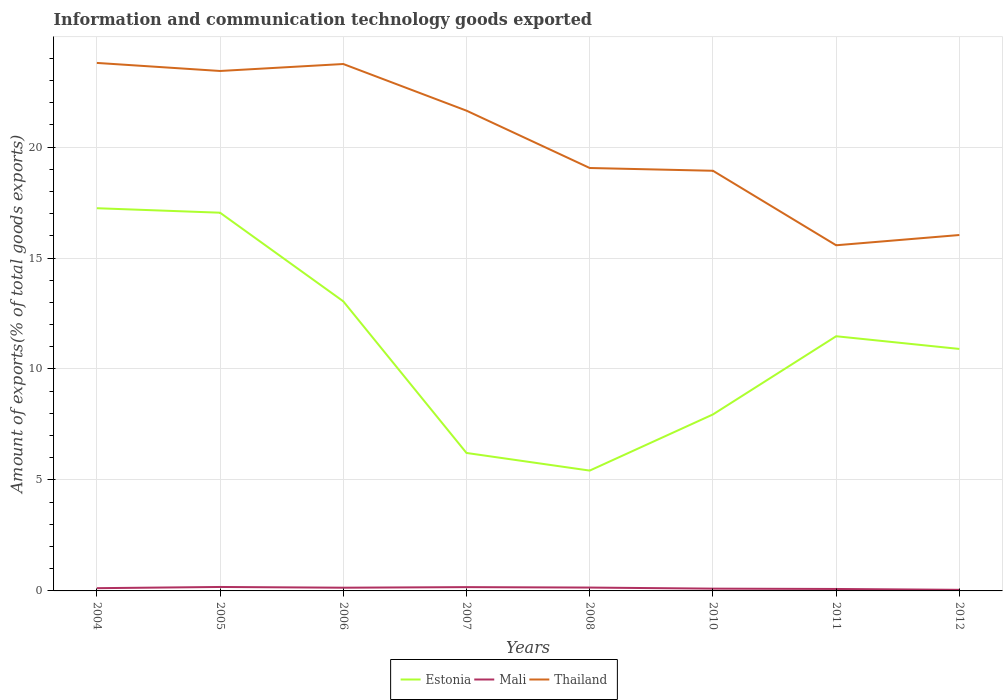Does the line corresponding to Mali intersect with the line corresponding to Thailand?
Offer a terse response. No. Across all years, what is the maximum amount of goods exported in Estonia?
Keep it short and to the point. 5.42. In which year was the amount of goods exported in Thailand maximum?
Offer a very short reply. 2011. What is the total amount of goods exported in Thailand in the graph?
Provide a succinct answer. 0.05. What is the difference between the highest and the second highest amount of goods exported in Thailand?
Provide a short and direct response. 8.22. What is the difference between the highest and the lowest amount of goods exported in Mali?
Your answer should be very brief. 4. How many lines are there?
Give a very brief answer. 3. Are the values on the major ticks of Y-axis written in scientific E-notation?
Your response must be concise. No. Does the graph contain any zero values?
Give a very brief answer. No. How many legend labels are there?
Your answer should be compact. 3. How are the legend labels stacked?
Ensure brevity in your answer.  Horizontal. What is the title of the graph?
Your answer should be compact. Information and communication technology goods exported. What is the label or title of the X-axis?
Ensure brevity in your answer.  Years. What is the label or title of the Y-axis?
Your answer should be compact. Amount of exports(% of total goods exports). What is the Amount of exports(% of total goods exports) of Estonia in 2004?
Your answer should be compact. 17.24. What is the Amount of exports(% of total goods exports) in Mali in 2004?
Provide a succinct answer. 0.12. What is the Amount of exports(% of total goods exports) in Thailand in 2004?
Your answer should be very brief. 23.79. What is the Amount of exports(% of total goods exports) of Estonia in 2005?
Your answer should be very brief. 17.04. What is the Amount of exports(% of total goods exports) of Mali in 2005?
Your response must be concise. 0.18. What is the Amount of exports(% of total goods exports) of Thailand in 2005?
Provide a succinct answer. 23.43. What is the Amount of exports(% of total goods exports) of Estonia in 2006?
Offer a very short reply. 13.05. What is the Amount of exports(% of total goods exports) in Mali in 2006?
Your response must be concise. 0.15. What is the Amount of exports(% of total goods exports) in Thailand in 2006?
Make the answer very short. 23.74. What is the Amount of exports(% of total goods exports) in Estonia in 2007?
Ensure brevity in your answer.  6.22. What is the Amount of exports(% of total goods exports) in Mali in 2007?
Make the answer very short. 0.17. What is the Amount of exports(% of total goods exports) in Thailand in 2007?
Provide a short and direct response. 21.64. What is the Amount of exports(% of total goods exports) of Estonia in 2008?
Keep it short and to the point. 5.42. What is the Amount of exports(% of total goods exports) in Mali in 2008?
Provide a succinct answer. 0.15. What is the Amount of exports(% of total goods exports) in Thailand in 2008?
Provide a short and direct response. 19.06. What is the Amount of exports(% of total goods exports) in Estonia in 2010?
Make the answer very short. 7.95. What is the Amount of exports(% of total goods exports) in Mali in 2010?
Provide a short and direct response. 0.1. What is the Amount of exports(% of total goods exports) in Thailand in 2010?
Provide a succinct answer. 18.93. What is the Amount of exports(% of total goods exports) in Estonia in 2011?
Give a very brief answer. 11.47. What is the Amount of exports(% of total goods exports) of Mali in 2011?
Your answer should be very brief. 0.09. What is the Amount of exports(% of total goods exports) of Thailand in 2011?
Your answer should be very brief. 15.57. What is the Amount of exports(% of total goods exports) in Estonia in 2012?
Ensure brevity in your answer.  10.9. What is the Amount of exports(% of total goods exports) of Mali in 2012?
Your answer should be very brief. 0.05. What is the Amount of exports(% of total goods exports) in Thailand in 2012?
Your response must be concise. 16.04. Across all years, what is the maximum Amount of exports(% of total goods exports) of Estonia?
Your answer should be compact. 17.24. Across all years, what is the maximum Amount of exports(% of total goods exports) in Mali?
Your answer should be very brief. 0.18. Across all years, what is the maximum Amount of exports(% of total goods exports) of Thailand?
Your answer should be very brief. 23.79. Across all years, what is the minimum Amount of exports(% of total goods exports) in Estonia?
Ensure brevity in your answer.  5.42. Across all years, what is the minimum Amount of exports(% of total goods exports) in Mali?
Make the answer very short. 0.05. Across all years, what is the minimum Amount of exports(% of total goods exports) of Thailand?
Provide a short and direct response. 15.57. What is the total Amount of exports(% of total goods exports) of Estonia in the graph?
Provide a succinct answer. 89.3. What is the total Amount of exports(% of total goods exports) of Mali in the graph?
Give a very brief answer. 1.01. What is the total Amount of exports(% of total goods exports) in Thailand in the graph?
Your answer should be compact. 162.19. What is the difference between the Amount of exports(% of total goods exports) in Estonia in 2004 and that in 2005?
Offer a terse response. 0.2. What is the difference between the Amount of exports(% of total goods exports) of Mali in 2004 and that in 2005?
Offer a terse response. -0.05. What is the difference between the Amount of exports(% of total goods exports) in Thailand in 2004 and that in 2005?
Make the answer very short. 0.36. What is the difference between the Amount of exports(% of total goods exports) of Estonia in 2004 and that in 2006?
Keep it short and to the point. 4.19. What is the difference between the Amount of exports(% of total goods exports) in Mali in 2004 and that in 2006?
Ensure brevity in your answer.  -0.02. What is the difference between the Amount of exports(% of total goods exports) of Thailand in 2004 and that in 2006?
Give a very brief answer. 0.05. What is the difference between the Amount of exports(% of total goods exports) in Estonia in 2004 and that in 2007?
Your response must be concise. 11.03. What is the difference between the Amount of exports(% of total goods exports) in Mali in 2004 and that in 2007?
Make the answer very short. -0.05. What is the difference between the Amount of exports(% of total goods exports) in Thailand in 2004 and that in 2007?
Provide a succinct answer. 2.15. What is the difference between the Amount of exports(% of total goods exports) of Estonia in 2004 and that in 2008?
Provide a short and direct response. 11.82. What is the difference between the Amount of exports(% of total goods exports) in Mali in 2004 and that in 2008?
Your response must be concise. -0.03. What is the difference between the Amount of exports(% of total goods exports) of Thailand in 2004 and that in 2008?
Your answer should be very brief. 4.73. What is the difference between the Amount of exports(% of total goods exports) in Estonia in 2004 and that in 2010?
Give a very brief answer. 9.29. What is the difference between the Amount of exports(% of total goods exports) of Mali in 2004 and that in 2010?
Ensure brevity in your answer.  0.02. What is the difference between the Amount of exports(% of total goods exports) of Thailand in 2004 and that in 2010?
Your answer should be very brief. 4.86. What is the difference between the Amount of exports(% of total goods exports) of Estonia in 2004 and that in 2011?
Your answer should be compact. 5.77. What is the difference between the Amount of exports(% of total goods exports) in Mali in 2004 and that in 2011?
Offer a terse response. 0.04. What is the difference between the Amount of exports(% of total goods exports) of Thailand in 2004 and that in 2011?
Keep it short and to the point. 8.22. What is the difference between the Amount of exports(% of total goods exports) in Estonia in 2004 and that in 2012?
Make the answer very short. 6.34. What is the difference between the Amount of exports(% of total goods exports) in Mali in 2004 and that in 2012?
Keep it short and to the point. 0.07. What is the difference between the Amount of exports(% of total goods exports) in Thailand in 2004 and that in 2012?
Make the answer very short. 7.75. What is the difference between the Amount of exports(% of total goods exports) of Estonia in 2005 and that in 2006?
Keep it short and to the point. 3.99. What is the difference between the Amount of exports(% of total goods exports) in Mali in 2005 and that in 2006?
Ensure brevity in your answer.  0.03. What is the difference between the Amount of exports(% of total goods exports) in Thailand in 2005 and that in 2006?
Provide a short and direct response. -0.31. What is the difference between the Amount of exports(% of total goods exports) of Estonia in 2005 and that in 2007?
Make the answer very short. 10.82. What is the difference between the Amount of exports(% of total goods exports) of Mali in 2005 and that in 2007?
Provide a short and direct response. 0.01. What is the difference between the Amount of exports(% of total goods exports) in Thailand in 2005 and that in 2007?
Provide a succinct answer. 1.79. What is the difference between the Amount of exports(% of total goods exports) of Estonia in 2005 and that in 2008?
Ensure brevity in your answer.  11.62. What is the difference between the Amount of exports(% of total goods exports) in Mali in 2005 and that in 2008?
Make the answer very short. 0.03. What is the difference between the Amount of exports(% of total goods exports) in Thailand in 2005 and that in 2008?
Offer a very short reply. 4.37. What is the difference between the Amount of exports(% of total goods exports) of Estonia in 2005 and that in 2010?
Make the answer very short. 9.09. What is the difference between the Amount of exports(% of total goods exports) in Mali in 2005 and that in 2010?
Offer a terse response. 0.07. What is the difference between the Amount of exports(% of total goods exports) of Thailand in 2005 and that in 2010?
Offer a terse response. 4.5. What is the difference between the Amount of exports(% of total goods exports) of Estonia in 2005 and that in 2011?
Ensure brevity in your answer.  5.57. What is the difference between the Amount of exports(% of total goods exports) of Mali in 2005 and that in 2011?
Ensure brevity in your answer.  0.09. What is the difference between the Amount of exports(% of total goods exports) of Thailand in 2005 and that in 2011?
Make the answer very short. 7.85. What is the difference between the Amount of exports(% of total goods exports) of Estonia in 2005 and that in 2012?
Ensure brevity in your answer.  6.14. What is the difference between the Amount of exports(% of total goods exports) in Mali in 2005 and that in 2012?
Offer a very short reply. 0.13. What is the difference between the Amount of exports(% of total goods exports) in Thailand in 2005 and that in 2012?
Your answer should be very brief. 7.39. What is the difference between the Amount of exports(% of total goods exports) in Estonia in 2006 and that in 2007?
Offer a terse response. 6.83. What is the difference between the Amount of exports(% of total goods exports) in Mali in 2006 and that in 2007?
Make the answer very short. -0.03. What is the difference between the Amount of exports(% of total goods exports) in Thailand in 2006 and that in 2007?
Offer a terse response. 2.1. What is the difference between the Amount of exports(% of total goods exports) of Estonia in 2006 and that in 2008?
Offer a very short reply. 7.63. What is the difference between the Amount of exports(% of total goods exports) in Mali in 2006 and that in 2008?
Your response must be concise. -0.01. What is the difference between the Amount of exports(% of total goods exports) in Thailand in 2006 and that in 2008?
Offer a terse response. 4.69. What is the difference between the Amount of exports(% of total goods exports) in Estonia in 2006 and that in 2010?
Give a very brief answer. 5.1. What is the difference between the Amount of exports(% of total goods exports) in Mali in 2006 and that in 2010?
Your answer should be very brief. 0.04. What is the difference between the Amount of exports(% of total goods exports) of Thailand in 2006 and that in 2010?
Your answer should be compact. 4.81. What is the difference between the Amount of exports(% of total goods exports) in Estonia in 2006 and that in 2011?
Provide a short and direct response. 1.57. What is the difference between the Amount of exports(% of total goods exports) of Mali in 2006 and that in 2011?
Ensure brevity in your answer.  0.06. What is the difference between the Amount of exports(% of total goods exports) in Thailand in 2006 and that in 2011?
Provide a succinct answer. 8.17. What is the difference between the Amount of exports(% of total goods exports) of Estonia in 2006 and that in 2012?
Ensure brevity in your answer.  2.15. What is the difference between the Amount of exports(% of total goods exports) in Mali in 2006 and that in 2012?
Give a very brief answer. 0.1. What is the difference between the Amount of exports(% of total goods exports) of Thailand in 2006 and that in 2012?
Make the answer very short. 7.7. What is the difference between the Amount of exports(% of total goods exports) in Estonia in 2007 and that in 2008?
Give a very brief answer. 0.79. What is the difference between the Amount of exports(% of total goods exports) in Mali in 2007 and that in 2008?
Your answer should be compact. 0.02. What is the difference between the Amount of exports(% of total goods exports) in Thailand in 2007 and that in 2008?
Keep it short and to the point. 2.58. What is the difference between the Amount of exports(% of total goods exports) in Estonia in 2007 and that in 2010?
Ensure brevity in your answer.  -1.74. What is the difference between the Amount of exports(% of total goods exports) in Mali in 2007 and that in 2010?
Your answer should be compact. 0.07. What is the difference between the Amount of exports(% of total goods exports) of Thailand in 2007 and that in 2010?
Your response must be concise. 2.71. What is the difference between the Amount of exports(% of total goods exports) of Estonia in 2007 and that in 2011?
Your answer should be very brief. -5.26. What is the difference between the Amount of exports(% of total goods exports) in Mali in 2007 and that in 2011?
Keep it short and to the point. 0.08. What is the difference between the Amount of exports(% of total goods exports) of Thailand in 2007 and that in 2011?
Make the answer very short. 6.06. What is the difference between the Amount of exports(% of total goods exports) in Estonia in 2007 and that in 2012?
Provide a short and direct response. -4.69. What is the difference between the Amount of exports(% of total goods exports) in Mali in 2007 and that in 2012?
Provide a succinct answer. 0.12. What is the difference between the Amount of exports(% of total goods exports) of Thailand in 2007 and that in 2012?
Provide a short and direct response. 5.6. What is the difference between the Amount of exports(% of total goods exports) in Estonia in 2008 and that in 2010?
Give a very brief answer. -2.53. What is the difference between the Amount of exports(% of total goods exports) of Mali in 2008 and that in 2010?
Provide a short and direct response. 0.05. What is the difference between the Amount of exports(% of total goods exports) in Thailand in 2008 and that in 2010?
Offer a very short reply. 0.12. What is the difference between the Amount of exports(% of total goods exports) of Estonia in 2008 and that in 2011?
Provide a succinct answer. -6.05. What is the difference between the Amount of exports(% of total goods exports) of Mali in 2008 and that in 2011?
Provide a short and direct response. 0.06. What is the difference between the Amount of exports(% of total goods exports) of Thailand in 2008 and that in 2011?
Give a very brief answer. 3.48. What is the difference between the Amount of exports(% of total goods exports) in Estonia in 2008 and that in 2012?
Offer a terse response. -5.48. What is the difference between the Amount of exports(% of total goods exports) of Mali in 2008 and that in 2012?
Offer a terse response. 0.1. What is the difference between the Amount of exports(% of total goods exports) of Thailand in 2008 and that in 2012?
Ensure brevity in your answer.  3.02. What is the difference between the Amount of exports(% of total goods exports) in Estonia in 2010 and that in 2011?
Your response must be concise. -3.52. What is the difference between the Amount of exports(% of total goods exports) of Mali in 2010 and that in 2011?
Ensure brevity in your answer.  0.02. What is the difference between the Amount of exports(% of total goods exports) in Thailand in 2010 and that in 2011?
Provide a succinct answer. 3.36. What is the difference between the Amount of exports(% of total goods exports) of Estonia in 2010 and that in 2012?
Provide a short and direct response. -2.95. What is the difference between the Amount of exports(% of total goods exports) in Mali in 2010 and that in 2012?
Ensure brevity in your answer.  0.05. What is the difference between the Amount of exports(% of total goods exports) of Thailand in 2010 and that in 2012?
Your response must be concise. 2.9. What is the difference between the Amount of exports(% of total goods exports) of Estonia in 2011 and that in 2012?
Make the answer very short. 0.57. What is the difference between the Amount of exports(% of total goods exports) in Mali in 2011 and that in 2012?
Offer a terse response. 0.04. What is the difference between the Amount of exports(% of total goods exports) in Thailand in 2011 and that in 2012?
Ensure brevity in your answer.  -0.46. What is the difference between the Amount of exports(% of total goods exports) of Estonia in 2004 and the Amount of exports(% of total goods exports) of Mali in 2005?
Offer a very short reply. 17.07. What is the difference between the Amount of exports(% of total goods exports) of Estonia in 2004 and the Amount of exports(% of total goods exports) of Thailand in 2005?
Your answer should be very brief. -6.18. What is the difference between the Amount of exports(% of total goods exports) of Mali in 2004 and the Amount of exports(% of total goods exports) of Thailand in 2005?
Provide a short and direct response. -23.3. What is the difference between the Amount of exports(% of total goods exports) in Estonia in 2004 and the Amount of exports(% of total goods exports) in Mali in 2006?
Your answer should be very brief. 17.1. What is the difference between the Amount of exports(% of total goods exports) of Estonia in 2004 and the Amount of exports(% of total goods exports) of Thailand in 2006?
Your answer should be compact. -6.5. What is the difference between the Amount of exports(% of total goods exports) in Mali in 2004 and the Amount of exports(% of total goods exports) in Thailand in 2006?
Give a very brief answer. -23.62. What is the difference between the Amount of exports(% of total goods exports) of Estonia in 2004 and the Amount of exports(% of total goods exports) of Mali in 2007?
Ensure brevity in your answer.  17.07. What is the difference between the Amount of exports(% of total goods exports) of Estonia in 2004 and the Amount of exports(% of total goods exports) of Thailand in 2007?
Provide a short and direct response. -4.4. What is the difference between the Amount of exports(% of total goods exports) of Mali in 2004 and the Amount of exports(% of total goods exports) of Thailand in 2007?
Keep it short and to the point. -21.51. What is the difference between the Amount of exports(% of total goods exports) in Estonia in 2004 and the Amount of exports(% of total goods exports) in Mali in 2008?
Keep it short and to the point. 17.09. What is the difference between the Amount of exports(% of total goods exports) of Estonia in 2004 and the Amount of exports(% of total goods exports) of Thailand in 2008?
Offer a terse response. -1.81. What is the difference between the Amount of exports(% of total goods exports) in Mali in 2004 and the Amount of exports(% of total goods exports) in Thailand in 2008?
Your response must be concise. -18.93. What is the difference between the Amount of exports(% of total goods exports) in Estonia in 2004 and the Amount of exports(% of total goods exports) in Mali in 2010?
Offer a terse response. 17.14. What is the difference between the Amount of exports(% of total goods exports) in Estonia in 2004 and the Amount of exports(% of total goods exports) in Thailand in 2010?
Keep it short and to the point. -1.69. What is the difference between the Amount of exports(% of total goods exports) of Mali in 2004 and the Amount of exports(% of total goods exports) of Thailand in 2010?
Your answer should be very brief. -18.81. What is the difference between the Amount of exports(% of total goods exports) in Estonia in 2004 and the Amount of exports(% of total goods exports) in Mali in 2011?
Provide a short and direct response. 17.16. What is the difference between the Amount of exports(% of total goods exports) in Estonia in 2004 and the Amount of exports(% of total goods exports) in Thailand in 2011?
Offer a terse response. 1.67. What is the difference between the Amount of exports(% of total goods exports) of Mali in 2004 and the Amount of exports(% of total goods exports) of Thailand in 2011?
Give a very brief answer. -15.45. What is the difference between the Amount of exports(% of total goods exports) of Estonia in 2004 and the Amount of exports(% of total goods exports) of Mali in 2012?
Provide a short and direct response. 17.19. What is the difference between the Amount of exports(% of total goods exports) in Estonia in 2004 and the Amount of exports(% of total goods exports) in Thailand in 2012?
Your answer should be compact. 1.21. What is the difference between the Amount of exports(% of total goods exports) in Mali in 2004 and the Amount of exports(% of total goods exports) in Thailand in 2012?
Your response must be concise. -15.91. What is the difference between the Amount of exports(% of total goods exports) of Estonia in 2005 and the Amount of exports(% of total goods exports) of Mali in 2006?
Your answer should be compact. 16.9. What is the difference between the Amount of exports(% of total goods exports) in Estonia in 2005 and the Amount of exports(% of total goods exports) in Thailand in 2006?
Your answer should be very brief. -6.7. What is the difference between the Amount of exports(% of total goods exports) of Mali in 2005 and the Amount of exports(% of total goods exports) of Thailand in 2006?
Your answer should be compact. -23.56. What is the difference between the Amount of exports(% of total goods exports) in Estonia in 2005 and the Amount of exports(% of total goods exports) in Mali in 2007?
Your answer should be compact. 16.87. What is the difference between the Amount of exports(% of total goods exports) of Estonia in 2005 and the Amount of exports(% of total goods exports) of Thailand in 2007?
Make the answer very short. -4.6. What is the difference between the Amount of exports(% of total goods exports) of Mali in 2005 and the Amount of exports(% of total goods exports) of Thailand in 2007?
Make the answer very short. -21.46. What is the difference between the Amount of exports(% of total goods exports) of Estonia in 2005 and the Amount of exports(% of total goods exports) of Mali in 2008?
Ensure brevity in your answer.  16.89. What is the difference between the Amount of exports(% of total goods exports) in Estonia in 2005 and the Amount of exports(% of total goods exports) in Thailand in 2008?
Keep it short and to the point. -2.01. What is the difference between the Amount of exports(% of total goods exports) in Mali in 2005 and the Amount of exports(% of total goods exports) in Thailand in 2008?
Provide a succinct answer. -18.88. What is the difference between the Amount of exports(% of total goods exports) of Estonia in 2005 and the Amount of exports(% of total goods exports) of Mali in 2010?
Provide a short and direct response. 16.94. What is the difference between the Amount of exports(% of total goods exports) of Estonia in 2005 and the Amount of exports(% of total goods exports) of Thailand in 2010?
Provide a short and direct response. -1.89. What is the difference between the Amount of exports(% of total goods exports) in Mali in 2005 and the Amount of exports(% of total goods exports) in Thailand in 2010?
Offer a terse response. -18.75. What is the difference between the Amount of exports(% of total goods exports) of Estonia in 2005 and the Amount of exports(% of total goods exports) of Mali in 2011?
Give a very brief answer. 16.95. What is the difference between the Amount of exports(% of total goods exports) of Estonia in 2005 and the Amount of exports(% of total goods exports) of Thailand in 2011?
Provide a succinct answer. 1.47. What is the difference between the Amount of exports(% of total goods exports) of Mali in 2005 and the Amount of exports(% of total goods exports) of Thailand in 2011?
Your response must be concise. -15.4. What is the difference between the Amount of exports(% of total goods exports) of Estonia in 2005 and the Amount of exports(% of total goods exports) of Mali in 2012?
Give a very brief answer. 16.99. What is the difference between the Amount of exports(% of total goods exports) of Estonia in 2005 and the Amount of exports(% of total goods exports) of Thailand in 2012?
Give a very brief answer. 1. What is the difference between the Amount of exports(% of total goods exports) in Mali in 2005 and the Amount of exports(% of total goods exports) in Thailand in 2012?
Give a very brief answer. -15.86. What is the difference between the Amount of exports(% of total goods exports) of Estonia in 2006 and the Amount of exports(% of total goods exports) of Mali in 2007?
Make the answer very short. 12.88. What is the difference between the Amount of exports(% of total goods exports) in Estonia in 2006 and the Amount of exports(% of total goods exports) in Thailand in 2007?
Your answer should be very brief. -8.59. What is the difference between the Amount of exports(% of total goods exports) of Mali in 2006 and the Amount of exports(% of total goods exports) of Thailand in 2007?
Ensure brevity in your answer.  -21.49. What is the difference between the Amount of exports(% of total goods exports) in Estonia in 2006 and the Amount of exports(% of total goods exports) in Mali in 2008?
Provide a succinct answer. 12.9. What is the difference between the Amount of exports(% of total goods exports) in Estonia in 2006 and the Amount of exports(% of total goods exports) in Thailand in 2008?
Your response must be concise. -6.01. What is the difference between the Amount of exports(% of total goods exports) of Mali in 2006 and the Amount of exports(% of total goods exports) of Thailand in 2008?
Offer a terse response. -18.91. What is the difference between the Amount of exports(% of total goods exports) in Estonia in 2006 and the Amount of exports(% of total goods exports) in Mali in 2010?
Offer a very short reply. 12.95. What is the difference between the Amount of exports(% of total goods exports) of Estonia in 2006 and the Amount of exports(% of total goods exports) of Thailand in 2010?
Keep it short and to the point. -5.88. What is the difference between the Amount of exports(% of total goods exports) in Mali in 2006 and the Amount of exports(% of total goods exports) in Thailand in 2010?
Provide a short and direct response. -18.79. What is the difference between the Amount of exports(% of total goods exports) in Estonia in 2006 and the Amount of exports(% of total goods exports) in Mali in 2011?
Give a very brief answer. 12.96. What is the difference between the Amount of exports(% of total goods exports) of Estonia in 2006 and the Amount of exports(% of total goods exports) of Thailand in 2011?
Your answer should be very brief. -2.53. What is the difference between the Amount of exports(% of total goods exports) of Mali in 2006 and the Amount of exports(% of total goods exports) of Thailand in 2011?
Offer a very short reply. -15.43. What is the difference between the Amount of exports(% of total goods exports) in Estonia in 2006 and the Amount of exports(% of total goods exports) in Mali in 2012?
Your answer should be compact. 13. What is the difference between the Amount of exports(% of total goods exports) in Estonia in 2006 and the Amount of exports(% of total goods exports) in Thailand in 2012?
Your answer should be very brief. -2.99. What is the difference between the Amount of exports(% of total goods exports) in Mali in 2006 and the Amount of exports(% of total goods exports) in Thailand in 2012?
Provide a succinct answer. -15.89. What is the difference between the Amount of exports(% of total goods exports) in Estonia in 2007 and the Amount of exports(% of total goods exports) in Mali in 2008?
Your answer should be very brief. 6.07. What is the difference between the Amount of exports(% of total goods exports) of Estonia in 2007 and the Amount of exports(% of total goods exports) of Thailand in 2008?
Your answer should be very brief. -12.84. What is the difference between the Amount of exports(% of total goods exports) of Mali in 2007 and the Amount of exports(% of total goods exports) of Thailand in 2008?
Your response must be concise. -18.88. What is the difference between the Amount of exports(% of total goods exports) of Estonia in 2007 and the Amount of exports(% of total goods exports) of Mali in 2010?
Your answer should be very brief. 6.11. What is the difference between the Amount of exports(% of total goods exports) in Estonia in 2007 and the Amount of exports(% of total goods exports) in Thailand in 2010?
Keep it short and to the point. -12.71. What is the difference between the Amount of exports(% of total goods exports) of Mali in 2007 and the Amount of exports(% of total goods exports) of Thailand in 2010?
Your response must be concise. -18.76. What is the difference between the Amount of exports(% of total goods exports) of Estonia in 2007 and the Amount of exports(% of total goods exports) of Mali in 2011?
Give a very brief answer. 6.13. What is the difference between the Amount of exports(% of total goods exports) in Estonia in 2007 and the Amount of exports(% of total goods exports) in Thailand in 2011?
Keep it short and to the point. -9.36. What is the difference between the Amount of exports(% of total goods exports) of Mali in 2007 and the Amount of exports(% of total goods exports) of Thailand in 2011?
Your answer should be compact. -15.4. What is the difference between the Amount of exports(% of total goods exports) of Estonia in 2007 and the Amount of exports(% of total goods exports) of Mali in 2012?
Your answer should be compact. 6.17. What is the difference between the Amount of exports(% of total goods exports) of Estonia in 2007 and the Amount of exports(% of total goods exports) of Thailand in 2012?
Offer a terse response. -9.82. What is the difference between the Amount of exports(% of total goods exports) of Mali in 2007 and the Amount of exports(% of total goods exports) of Thailand in 2012?
Make the answer very short. -15.87. What is the difference between the Amount of exports(% of total goods exports) in Estonia in 2008 and the Amount of exports(% of total goods exports) in Mali in 2010?
Make the answer very short. 5.32. What is the difference between the Amount of exports(% of total goods exports) of Estonia in 2008 and the Amount of exports(% of total goods exports) of Thailand in 2010?
Your response must be concise. -13.51. What is the difference between the Amount of exports(% of total goods exports) in Mali in 2008 and the Amount of exports(% of total goods exports) in Thailand in 2010?
Keep it short and to the point. -18.78. What is the difference between the Amount of exports(% of total goods exports) in Estonia in 2008 and the Amount of exports(% of total goods exports) in Mali in 2011?
Offer a terse response. 5.33. What is the difference between the Amount of exports(% of total goods exports) in Estonia in 2008 and the Amount of exports(% of total goods exports) in Thailand in 2011?
Keep it short and to the point. -10.15. What is the difference between the Amount of exports(% of total goods exports) in Mali in 2008 and the Amount of exports(% of total goods exports) in Thailand in 2011?
Make the answer very short. -15.42. What is the difference between the Amount of exports(% of total goods exports) in Estonia in 2008 and the Amount of exports(% of total goods exports) in Mali in 2012?
Your answer should be very brief. 5.37. What is the difference between the Amount of exports(% of total goods exports) in Estonia in 2008 and the Amount of exports(% of total goods exports) in Thailand in 2012?
Offer a very short reply. -10.61. What is the difference between the Amount of exports(% of total goods exports) in Mali in 2008 and the Amount of exports(% of total goods exports) in Thailand in 2012?
Give a very brief answer. -15.88. What is the difference between the Amount of exports(% of total goods exports) of Estonia in 2010 and the Amount of exports(% of total goods exports) of Mali in 2011?
Offer a terse response. 7.86. What is the difference between the Amount of exports(% of total goods exports) in Estonia in 2010 and the Amount of exports(% of total goods exports) in Thailand in 2011?
Offer a very short reply. -7.62. What is the difference between the Amount of exports(% of total goods exports) of Mali in 2010 and the Amount of exports(% of total goods exports) of Thailand in 2011?
Provide a short and direct response. -15.47. What is the difference between the Amount of exports(% of total goods exports) in Estonia in 2010 and the Amount of exports(% of total goods exports) in Mali in 2012?
Give a very brief answer. 7.9. What is the difference between the Amount of exports(% of total goods exports) of Estonia in 2010 and the Amount of exports(% of total goods exports) of Thailand in 2012?
Your answer should be very brief. -8.08. What is the difference between the Amount of exports(% of total goods exports) of Mali in 2010 and the Amount of exports(% of total goods exports) of Thailand in 2012?
Your response must be concise. -15.93. What is the difference between the Amount of exports(% of total goods exports) of Estonia in 2011 and the Amount of exports(% of total goods exports) of Mali in 2012?
Provide a short and direct response. 11.43. What is the difference between the Amount of exports(% of total goods exports) of Estonia in 2011 and the Amount of exports(% of total goods exports) of Thailand in 2012?
Your answer should be compact. -4.56. What is the difference between the Amount of exports(% of total goods exports) of Mali in 2011 and the Amount of exports(% of total goods exports) of Thailand in 2012?
Your answer should be compact. -15.95. What is the average Amount of exports(% of total goods exports) of Estonia per year?
Offer a terse response. 11.16. What is the average Amount of exports(% of total goods exports) of Mali per year?
Give a very brief answer. 0.13. What is the average Amount of exports(% of total goods exports) of Thailand per year?
Your answer should be very brief. 20.27. In the year 2004, what is the difference between the Amount of exports(% of total goods exports) of Estonia and Amount of exports(% of total goods exports) of Mali?
Ensure brevity in your answer.  17.12. In the year 2004, what is the difference between the Amount of exports(% of total goods exports) of Estonia and Amount of exports(% of total goods exports) of Thailand?
Provide a succinct answer. -6.55. In the year 2004, what is the difference between the Amount of exports(% of total goods exports) of Mali and Amount of exports(% of total goods exports) of Thailand?
Provide a succinct answer. -23.67. In the year 2005, what is the difference between the Amount of exports(% of total goods exports) of Estonia and Amount of exports(% of total goods exports) of Mali?
Your answer should be compact. 16.86. In the year 2005, what is the difference between the Amount of exports(% of total goods exports) in Estonia and Amount of exports(% of total goods exports) in Thailand?
Provide a succinct answer. -6.39. In the year 2005, what is the difference between the Amount of exports(% of total goods exports) of Mali and Amount of exports(% of total goods exports) of Thailand?
Offer a terse response. -23.25. In the year 2006, what is the difference between the Amount of exports(% of total goods exports) in Estonia and Amount of exports(% of total goods exports) in Mali?
Your answer should be compact. 12.9. In the year 2006, what is the difference between the Amount of exports(% of total goods exports) in Estonia and Amount of exports(% of total goods exports) in Thailand?
Keep it short and to the point. -10.69. In the year 2006, what is the difference between the Amount of exports(% of total goods exports) of Mali and Amount of exports(% of total goods exports) of Thailand?
Provide a short and direct response. -23.6. In the year 2007, what is the difference between the Amount of exports(% of total goods exports) of Estonia and Amount of exports(% of total goods exports) of Mali?
Offer a terse response. 6.05. In the year 2007, what is the difference between the Amount of exports(% of total goods exports) of Estonia and Amount of exports(% of total goods exports) of Thailand?
Provide a succinct answer. -15.42. In the year 2007, what is the difference between the Amount of exports(% of total goods exports) in Mali and Amount of exports(% of total goods exports) in Thailand?
Offer a terse response. -21.47. In the year 2008, what is the difference between the Amount of exports(% of total goods exports) of Estonia and Amount of exports(% of total goods exports) of Mali?
Your answer should be very brief. 5.27. In the year 2008, what is the difference between the Amount of exports(% of total goods exports) in Estonia and Amount of exports(% of total goods exports) in Thailand?
Ensure brevity in your answer.  -13.63. In the year 2008, what is the difference between the Amount of exports(% of total goods exports) of Mali and Amount of exports(% of total goods exports) of Thailand?
Your answer should be compact. -18.9. In the year 2010, what is the difference between the Amount of exports(% of total goods exports) of Estonia and Amount of exports(% of total goods exports) of Mali?
Keep it short and to the point. 7.85. In the year 2010, what is the difference between the Amount of exports(% of total goods exports) in Estonia and Amount of exports(% of total goods exports) in Thailand?
Offer a very short reply. -10.98. In the year 2010, what is the difference between the Amount of exports(% of total goods exports) of Mali and Amount of exports(% of total goods exports) of Thailand?
Your answer should be very brief. -18.83. In the year 2011, what is the difference between the Amount of exports(% of total goods exports) in Estonia and Amount of exports(% of total goods exports) in Mali?
Your answer should be very brief. 11.39. In the year 2011, what is the difference between the Amount of exports(% of total goods exports) of Estonia and Amount of exports(% of total goods exports) of Thailand?
Provide a short and direct response. -4.1. In the year 2011, what is the difference between the Amount of exports(% of total goods exports) of Mali and Amount of exports(% of total goods exports) of Thailand?
Offer a terse response. -15.49. In the year 2012, what is the difference between the Amount of exports(% of total goods exports) in Estonia and Amount of exports(% of total goods exports) in Mali?
Your response must be concise. 10.85. In the year 2012, what is the difference between the Amount of exports(% of total goods exports) of Estonia and Amount of exports(% of total goods exports) of Thailand?
Give a very brief answer. -5.13. In the year 2012, what is the difference between the Amount of exports(% of total goods exports) of Mali and Amount of exports(% of total goods exports) of Thailand?
Make the answer very short. -15.99. What is the ratio of the Amount of exports(% of total goods exports) in Estonia in 2004 to that in 2005?
Provide a short and direct response. 1.01. What is the ratio of the Amount of exports(% of total goods exports) in Mali in 2004 to that in 2005?
Make the answer very short. 0.7. What is the ratio of the Amount of exports(% of total goods exports) in Thailand in 2004 to that in 2005?
Provide a succinct answer. 1.02. What is the ratio of the Amount of exports(% of total goods exports) in Estonia in 2004 to that in 2006?
Provide a short and direct response. 1.32. What is the ratio of the Amount of exports(% of total goods exports) in Mali in 2004 to that in 2006?
Keep it short and to the point. 0.85. What is the ratio of the Amount of exports(% of total goods exports) of Estonia in 2004 to that in 2007?
Make the answer very short. 2.77. What is the ratio of the Amount of exports(% of total goods exports) in Mali in 2004 to that in 2007?
Your answer should be compact. 0.73. What is the ratio of the Amount of exports(% of total goods exports) of Thailand in 2004 to that in 2007?
Your answer should be very brief. 1.1. What is the ratio of the Amount of exports(% of total goods exports) in Estonia in 2004 to that in 2008?
Offer a very short reply. 3.18. What is the ratio of the Amount of exports(% of total goods exports) in Mali in 2004 to that in 2008?
Provide a short and direct response. 0.82. What is the ratio of the Amount of exports(% of total goods exports) in Thailand in 2004 to that in 2008?
Offer a terse response. 1.25. What is the ratio of the Amount of exports(% of total goods exports) in Estonia in 2004 to that in 2010?
Make the answer very short. 2.17. What is the ratio of the Amount of exports(% of total goods exports) in Mali in 2004 to that in 2010?
Ensure brevity in your answer.  1.2. What is the ratio of the Amount of exports(% of total goods exports) in Thailand in 2004 to that in 2010?
Offer a terse response. 1.26. What is the ratio of the Amount of exports(% of total goods exports) in Estonia in 2004 to that in 2011?
Ensure brevity in your answer.  1.5. What is the ratio of the Amount of exports(% of total goods exports) in Mali in 2004 to that in 2011?
Provide a succinct answer. 1.41. What is the ratio of the Amount of exports(% of total goods exports) of Thailand in 2004 to that in 2011?
Ensure brevity in your answer.  1.53. What is the ratio of the Amount of exports(% of total goods exports) of Estonia in 2004 to that in 2012?
Your answer should be compact. 1.58. What is the ratio of the Amount of exports(% of total goods exports) in Mali in 2004 to that in 2012?
Your answer should be compact. 2.5. What is the ratio of the Amount of exports(% of total goods exports) of Thailand in 2004 to that in 2012?
Keep it short and to the point. 1.48. What is the ratio of the Amount of exports(% of total goods exports) of Estonia in 2005 to that in 2006?
Give a very brief answer. 1.31. What is the ratio of the Amount of exports(% of total goods exports) of Mali in 2005 to that in 2006?
Ensure brevity in your answer.  1.22. What is the ratio of the Amount of exports(% of total goods exports) in Thailand in 2005 to that in 2006?
Give a very brief answer. 0.99. What is the ratio of the Amount of exports(% of total goods exports) of Estonia in 2005 to that in 2007?
Provide a succinct answer. 2.74. What is the ratio of the Amount of exports(% of total goods exports) in Mali in 2005 to that in 2007?
Give a very brief answer. 1.04. What is the ratio of the Amount of exports(% of total goods exports) of Thailand in 2005 to that in 2007?
Provide a short and direct response. 1.08. What is the ratio of the Amount of exports(% of total goods exports) of Estonia in 2005 to that in 2008?
Your response must be concise. 3.14. What is the ratio of the Amount of exports(% of total goods exports) of Mali in 2005 to that in 2008?
Keep it short and to the point. 1.18. What is the ratio of the Amount of exports(% of total goods exports) in Thailand in 2005 to that in 2008?
Keep it short and to the point. 1.23. What is the ratio of the Amount of exports(% of total goods exports) of Estonia in 2005 to that in 2010?
Your response must be concise. 2.14. What is the ratio of the Amount of exports(% of total goods exports) of Mali in 2005 to that in 2010?
Make the answer very short. 1.73. What is the ratio of the Amount of exports(% of total goods exports) of Thailand in 2005 to that in 2010?
Give a very brief answer. 1.24. What is the ratio of the Amount of exports(% of total goods exports) of Estonia in 2005 to that in 2011?
Ensure brevity in your answer.  1.49. What is the ratio of the Amount of exports(% of total goods exports) in Mali in 2005 to that in 2011?
Offer a terse response. 2.03. What is the ratio of the Amount of exports(% of total goods exports) in Thailand in 2005 to that in 2011?
Your answer should be compact. 1.5. What is the ratio of the Amount of exports(% of total goods exports) of Estonia in 2005 to that in 2012?
Your answer should be very brief. 1.56. What is the ratio of the Amount of exports(% of total goods exports) in Mali in 2005 to that in 2012?
Provide a succinct answer. 3.59. What is the ratio of the Amount of exports(% of total goods exports) of Thailand in 2005 to that in 2012?
Give a very brief answer. 1.46. What is the ratio of the Amount of exports(% of total goods exports) of Estonia in 2006 to that in 2007?
Your answer should be very brief. 2.1. What is the ratio of the Amount of exports(% of total goods exports) in Mali in 2006 to that in 2007?
Provide a short and direct response. 0.85. What is the ratio of the Amount of exports(% of total goods exports) in Thailand in 2006 to that in 2007?
Ensure brevity in your answer.  1.1. What is the ratio of the Amount of exports(% of total goods exports) of Estonia in 2006 to that in 2008?
Your response must be concise. 2.41. What is the ratio of the Amount of exports(% of total goods exports) in Mali in 2006 to that in 2008?
Provide a short and direct response. 0.96. What is the ratio of the Amount of exports(% of total goods exports) in Thailand in 2006 to that in 2008?
Make the answer very short. 1.25. What is the ratio of the Amount of exports(% of total goods exports) in Estonia in 2006 to that in 2010?
Make the answer very short. 1.64. What is the ratio of the Amount of exports(% of total goods exports) of Mali in 2006 to that in 2010?
Provide a succinct answer. 1.41. What is the ratio of the Amount of exports(% of total goods exports) in Thailand in 2006 to that in 2010?
Keep it short and to the point. 1.25. What is the ratio of the Amount of exports(% of total goods exports) in Estonia in 2006 to that in 2011?
Offer a terse response. 1.14. What is the ratio of the Amount of exports(% of total goods exports) in Mali in 2006 to that in 2011?
Your answer should be very brief. 1.65. What is the ratio of the Amount of exports(% of total goods exports) in Thailand in 2006 to that in 2011?
Ensure brevity in your answer.  1.52. What is the ratio of the Amount of exports(% of total goods exports) of Estonia in 2006 to that in 2012?
Your answer should be compact. 1.2. What is the ratio of the Amount of exports(% of total goods exports) of Mali in 2006 to that in 2012?
Make the answer very short. 2.93. What is the ratio of the Amount of exports(% of total goods exports) in Thailand in 2006 to that in 2012?
Make the answer very short. 1.48. What is the ratio of the Amount of exports(% of total goods exports) in Estonia in 2007 to that in 2008?
Offer a very short reply. 1.15. What is the ratio of the Amount of exports(% of total goods exports) in Mali in 2007 to that in 2008?
Make the answer very short. 1.13. What is the ratio of the Amount of exports(% of total goods exports) in Thailand in 2007 to that in 2008?
Offer a terse response. 1.14. What is the ratio of the Amount of exports(% of total goods exports) in Estonia in 2007 to that in 2010?
Your answer should be compact. 0.78. What is the ratio of the Amount of exports(% of total goods exports) in Mali in 2007 to that in 2010?
Your answer should be very brief. 1.66. What is the ratio of the Amount of exports(% of total goods exports) of Thailand in 2007 to that in 2010?
Offer a very short reply. 1.14. What is the ratio of the Amount of exports(% of total goods exports) of Estonia in 2007 to that in 2011?
Keep it short and to the point. 0.54. What is the ratio of the Amount of exports(% of total goods exports) in Mali in 2007 to that in 2011?
Provide a succinct answer. 1.94. What is the ratio of the Amount of exports(% of total goods exports) of Thailand in 2007 to that in 2011?
Your answer should be very brief. 1.39. What is the ratio of the Amount of exports(% of total goods exports) of Estonia in 2007 to that in 2012?
Offer a terse response. 0.57. What is the ratio of the Amount of exports(% of total goods exports) in Mali in 2007 to that in 2012?
Keep it short and to the point. 3.45. What is the ratio of the Amount of exports(% of total goods exports) of Thailand in 2007 to that in 2012?
Offer a terse response. 1.35. What is the ratio of the Amount of exports(% of total goods exports) in Estonia in 2008 to that in 2010?
Your response must be concise. 0.68. What is the ratio of the Amount of exports(% of total goods exports) in Mali in 2008 to that in 2010?
Your response must be concise. 1.47. What is the ratio of the Amount of exports(% of total goods exports) in Thailand in 2008 to that in 2010?
Keep it short and to the point. 1.01. What is the ratio of the Amount of exports(% of total goods exports) of Estonia in 2008 to that in 2011?
Make the answer very short. 0.47. What is the ratio of the Amount of exports(% of total goods exports) in Mali in 2008 to that in 2011?
Keep it short and to the point. 1.72. What is the ratio of the Amount of exports(% of total goods exports) of Thailand in 2008 to that in 2011?
Provide a succinct answer. 1.22. What is the ratio of the Amount of exports(% of total goods exports) in Estonia in 2008 to that in 2012?
Offer a very short reply. 0.5. What is the ratio of the Amount of exports(% of total goods exports) in Mali in 2008 to that in 2012?
Offer a terse response. 3.05. What is the ratio of the Amount of exports(% of total goods exports) of Thailand in 2008 to that in 2012?
Make the answer very short. 1.19. What is the ratio of the Amount of exports(% of total goods exports) of Estonia in 2010 to that in 2011?
Offer a terse response. 0.69. What is the ratio of the Amount of exports(% of total goods exports) in Mali in 2010 to that in 2011?
Your answer should be compact. 1.17. What is the ratio of the Amount of exports(% of total goods exports) in Thailand in 2010 to that in 2011?
Make the answer very short. 1.22. What is the ratio of the Amount of exports(% of total goods exports) of Estonia in 2010 to that in 2012?
Provide a succinct answer. 0.73. What is the ratio of the Amount of exports(% of total goods exports) in Mali in 2010 to that in 2012?
Offer a very short reply. 2.08. What is the ratio of the Amount of exports(% of total goods exports) in Thailand in 2010 to that in 2012?
Offer a very short reply. 1.18. What is the ratio of the Amount of exports(% of total goods exports) in Estonia in 2011 to that in 2012?
Your answer should be compact. 1.05. What is the ratio of the Amount of exports(% of total goods exports) of Mali in 2011 to that in 2012?
Offer a very short reply. 1.77. What is the ratio of the Amount of exports(% of total goods exports) in Thailand in 2011 to that in 2012?
Your answer should be compact. 0.97. What is the difference between the highest and the second highest Amount of exports(% of total goods exports) in Estonia?
Offer a terse response. 0.2. What is the difference between the highest and the second highest Amount of exports(% of total goods exports) of Mali?
Your response must be concise. 0.01. What is the difference between the highest and the second highest Amount of exports(% of total goods exports) of Thailand?
Give a very brief answer. 0.05. What is the difference between the highest and the lowest Amount of exports(% of total goods exports) in Estonia?
Provide a short and direct response. 11.82. What is the difference between the highest and the lowest Amount of exports(% of total goods exports) of Mali?
Keep it short and to the point. 0.13. What is the difference between the highest and the lowest Amount of exports(% of total goods exports) in Thailand?
Keep it short and to the point. 8.22. 